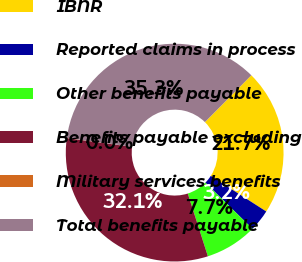Convert chart. <chart><loc_0><loc_0><loc_500><loc_500><pie_chart><fcel>IBNR<fcel>Reported claims in process<fcel>Other benefits payable<fcel>Benefits payable excluding<fcel>Military services benefits<fcel>Total benefits payable<nl><fcel>21.66%<fcel>3.24%<fcel>7.73%<fcel>32.06%<fcel>0.03%<fcel>35.27%<nl></chart> 